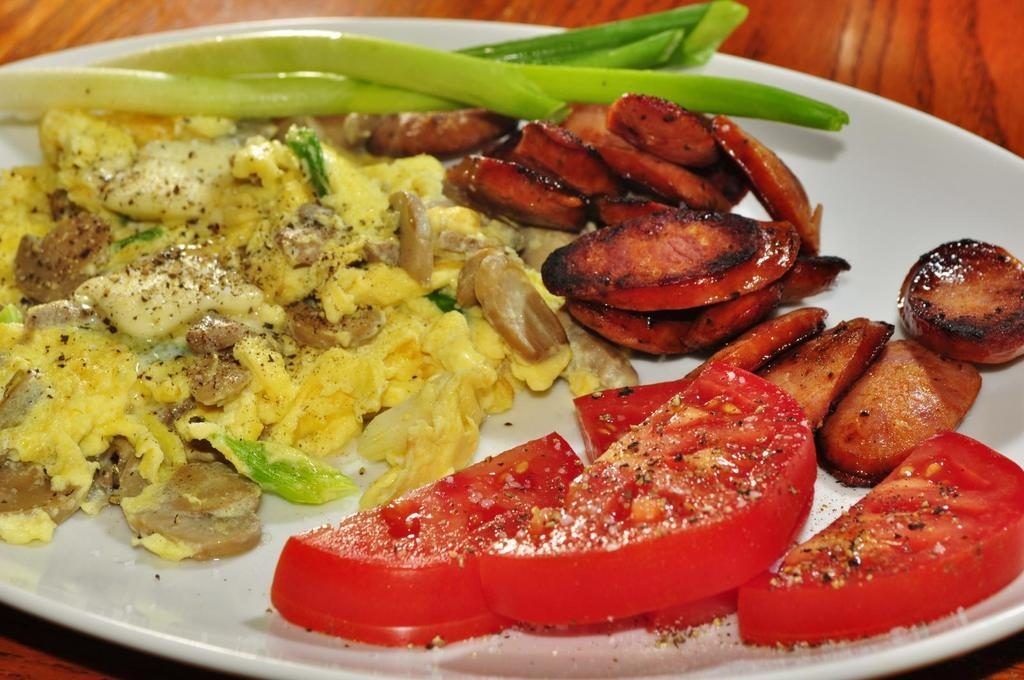What is present on the plate in the image? There is food on the plate in the image. Where is the plate with food located? The plate with food is on a table in the image. What advice is given by the cakes in the image? There are no cakes present in the image, so no advice can be given by them. 